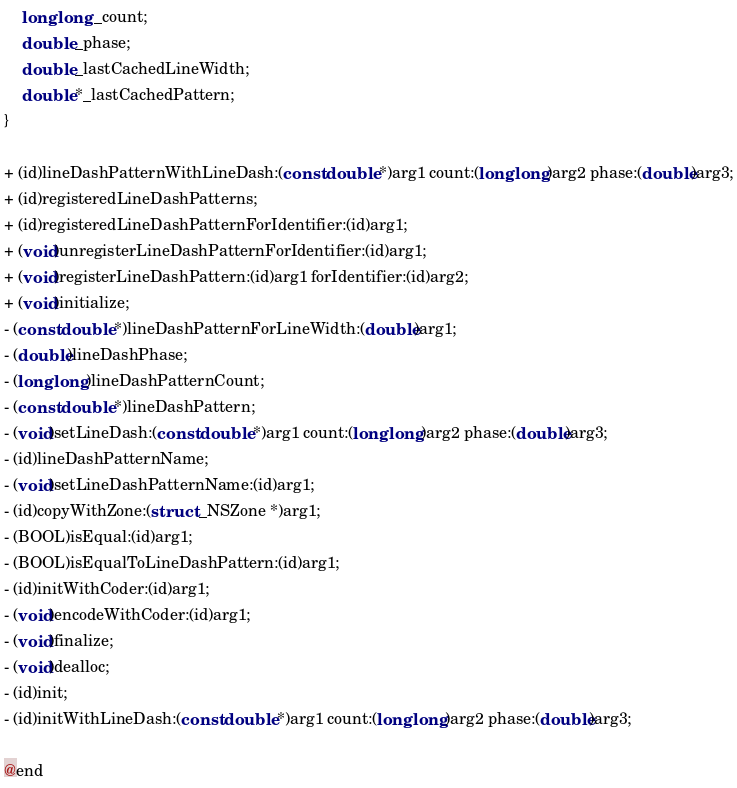Convert code to text. <code><loc_0><loc_0><loc_500><loc_500><_C_>    long long _count;
    double _phase;
    double _lastCachedLineWidth;
    double *_lastCachedPattern;
}

+ (id)lineDashPatternWithLineDash:(const double *)arg1 count:(long long)arg2 phase:(double)arg3;
+ (id)registeredLineDashPatterns;
+ (id)registeredLineDashPatternForIdentifier:(id)arg1;
+ (void)unregisterLineDashPatternForIdentifier:(id)arg1;
+ (void)registerLineDashPattern:(id)arg1 forIdentifier:(id)arg2;
+ (void)initialize;
- (const double *)lineDashPatternForLineWidth:(double)arg1;
- (double)lineDashPhase;
- (long long)lineDashPatternCount;
- (const double *)lineDashPattern;
- (void)setLineDash:(const double *)arg1 count:(long long)arg2 phase:(double)arg3;
- (id)lineDashPatternName;
- (void)setLineDashPatternName:(id)arg1;
- (id)copyWithZone:(struct _NSZone *)arg1;
- (BOOL)isEqual:(id)arg1;
- (BOOL)isEqualToLineDashPattern:(id)arg1;
- (id)initWithCoder:(id)arg1;
- (void)encodeWithCoder:(id)arg1;
- (void)finalize;
- (void)dealloc;
- (id)init;
- (id)initWithLineDash:(const double *)arg1 count:(long long)arg2 phase:(double)arg3;

@end

</code> 